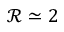Convert formula to latex. <formula><loc_0><loc_0><loc_500><loc_500>\mathcal { R } \simeq 2</formula> 